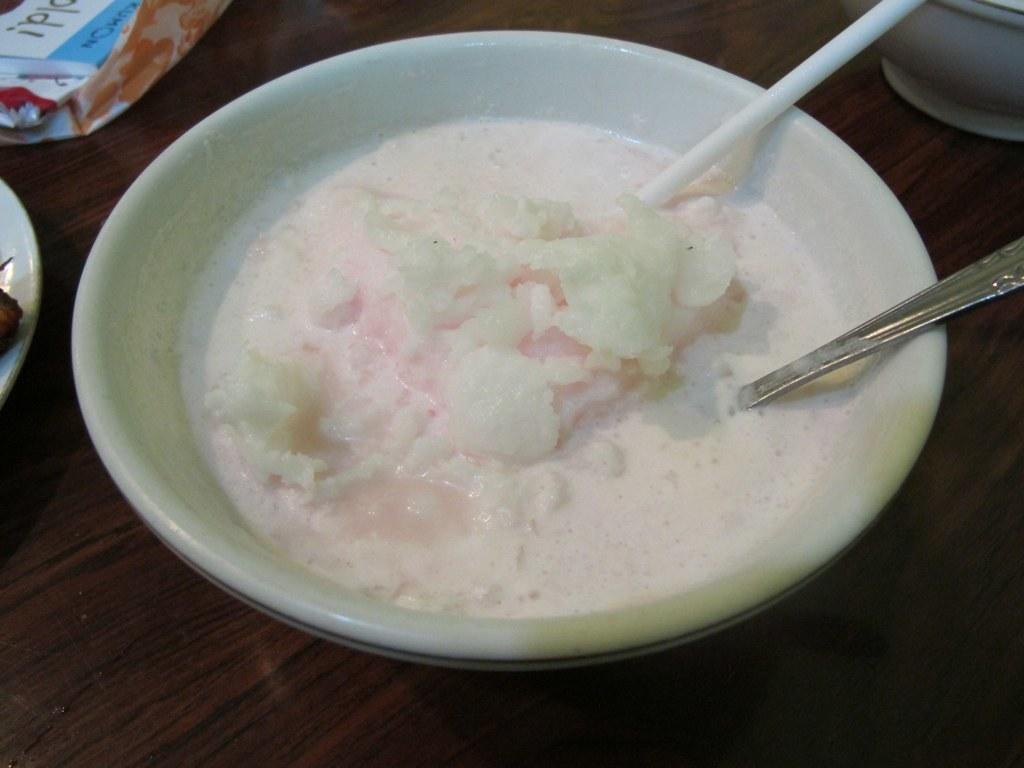What piece of furniture is present in the image? There is a table in the image. What is in the bowl that is on the table? There is a bowl containing a dessert in the image. What utensil is visible in the image? A spoon is visible in the image. What is placed on the table alongside the bowl and spoon? There is a plate in the image. What other object can be seen on the table? There is a box placed on the table in the image. What type of cloud is visible in the image? There is no cloud present in the image; it is a close-up shot of a table with various items on it. 